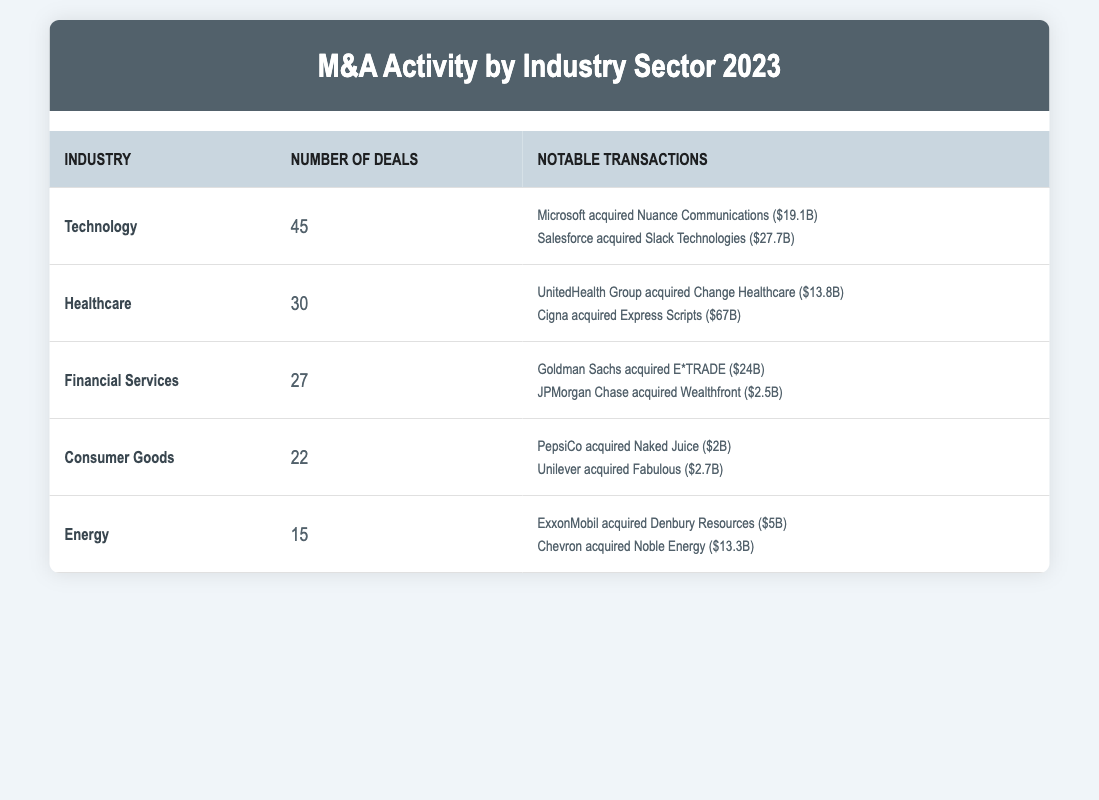What industry had the highest number of deals in 2023? The industry with the highest number of deals can be found by comparing the "Number of Deals" column. Technology has 45 deals, which is the highest among all industries listed.
Answer: Technology How many deals did the Healthcare sector have? The number of deals in the Healthcare sector is directly listed in the table, which shows that there were 30 deals for this industry.
Answer: 30 What is the total number of deals across all industries? To find the total number of deals, we add the number of deals for each industry: (45 + 30 + 27 + 22 + 15) = 139.
Answer: 139 Did the Energy sector have more deals than the Consumer Goods sector? Comparing the number of deals, the Energy sector has 15 deals while the Consumer Goods sector has 22 deals. Therefore, Energy did not have more deals than Consumer Goods.
Answer: No Which industry had the highest deal value for a single transaction, and what was that value? By reviewing the notable transactions, the highest deal value is from Cigna's acquisition of Express Scripts at $67 billion. Therefore, Healthcare industry had the highest single deal value.
Answer: Healthcare, $67 billion How many more deals did the Financial Services sector have compared to the Energy sector? To find the difference, subtract the number of deals in the Energy sector (15) from the number of deals in the Financial Services sector (27): 27 - 15 = 12.
Answer: 12 Is it true that Microsoft was involved in more than one notable transaction? Checking the notable transactions section, Microsoft is listed as an acquirer only once (acquiring Nuance Communications). Thus, it is not true that Microsoft was involved in more than one notable transaction.
Answer: No What is the average number of deals for the top three industries by deal count? The top three industries by deal count are Technology (45), Healthcare (30), and Financial Services (27). To find the average, sum these deals (45 + 30 + 27 = 102) and divide by 3: 102/3 = 34.
Answer: 34 Which industry had the least number of deals, and how many were there? The least number of deals is found by looking at the "Number of Deals" column, where the Energy sector has 15 deals, the smallest number among all listed.
Answer: Energy, 15 